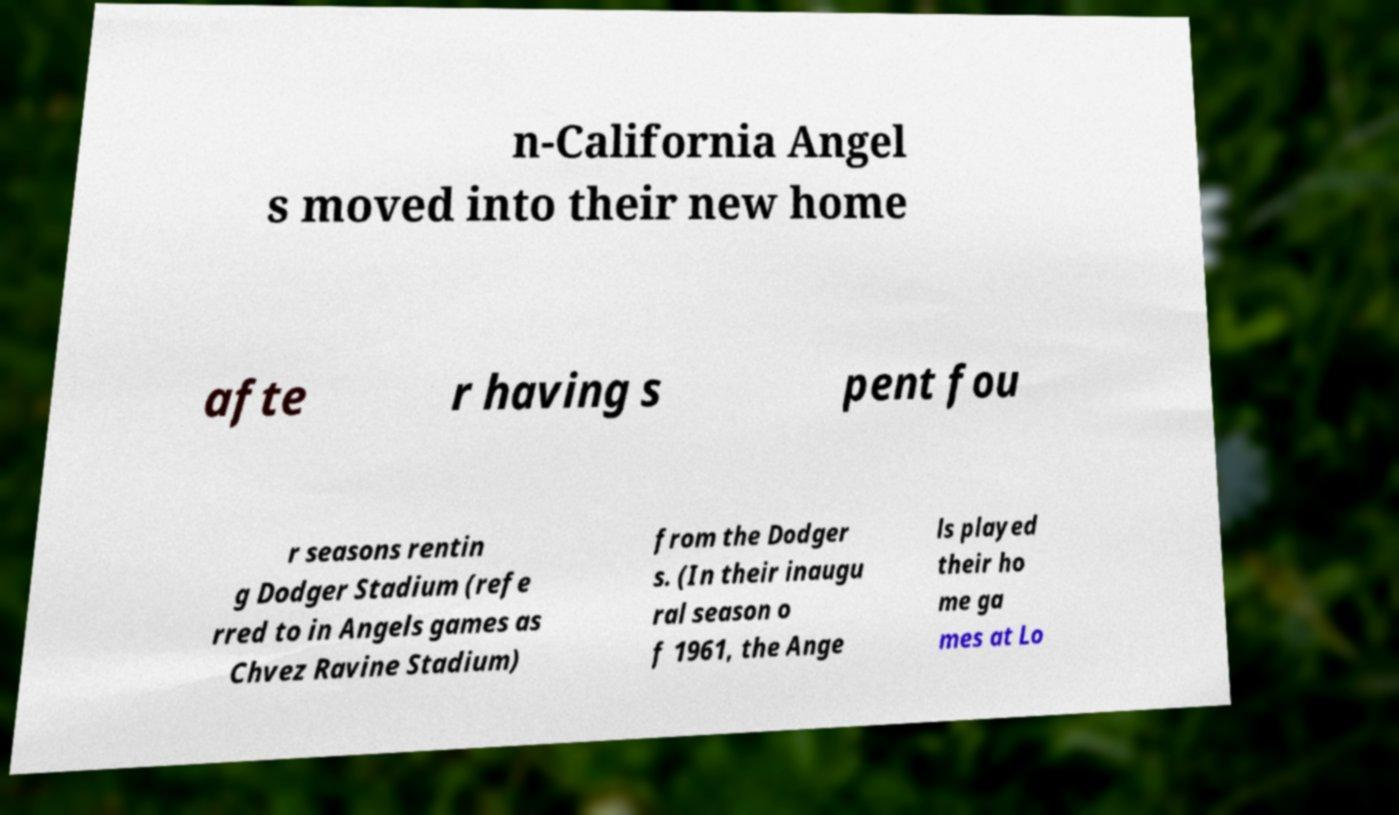For documentation purposes, I need the text within this image transcribed. Could you provide that? n-California Angel s moved into their new home afte r having s pent fou r seasons rentin g Dodger Stadium (refe rred to in Angels games as Chvez Ravine Stadium) from the Dodger s. (In their inaugu ral season o f 1961, the Ange ls played their ho me ga mes at Lo 